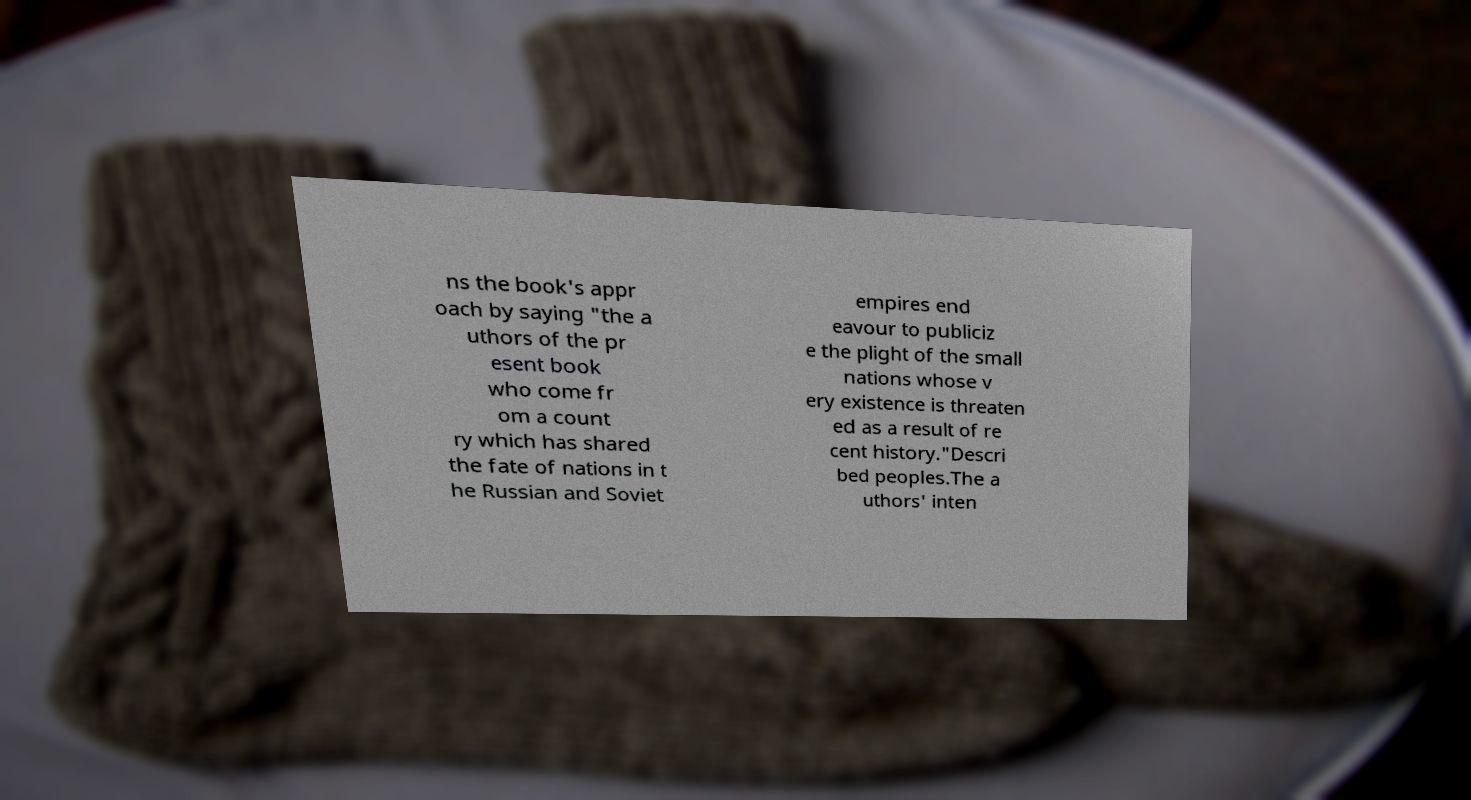Please read and relay the text visible in this image. What does it say? ns the book's appr oach by saying "the a uthors of the pr esent book who come fr om a count ry which has shared the fate of nations in t he Russian and Soviet empires end eavour to publiciz e the plight of the small nations whose v ery existence is threaten ed as a result of re cent history."Descri bed peoples.The a uthors' inten 